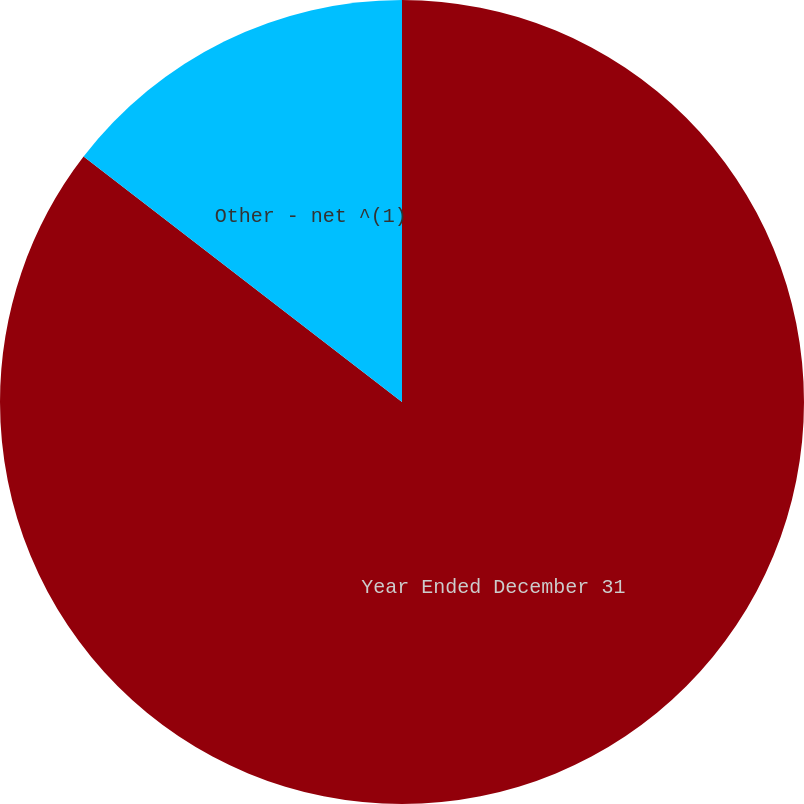Convert chart. <chart><loc_0><loc_0><loc_500><loc_500><pie_chart><fcel>Year Ended December 31<fcel>Other - net ^(1)<nl><fcel>85.45%<fcel>14.55%<nl></chart> 